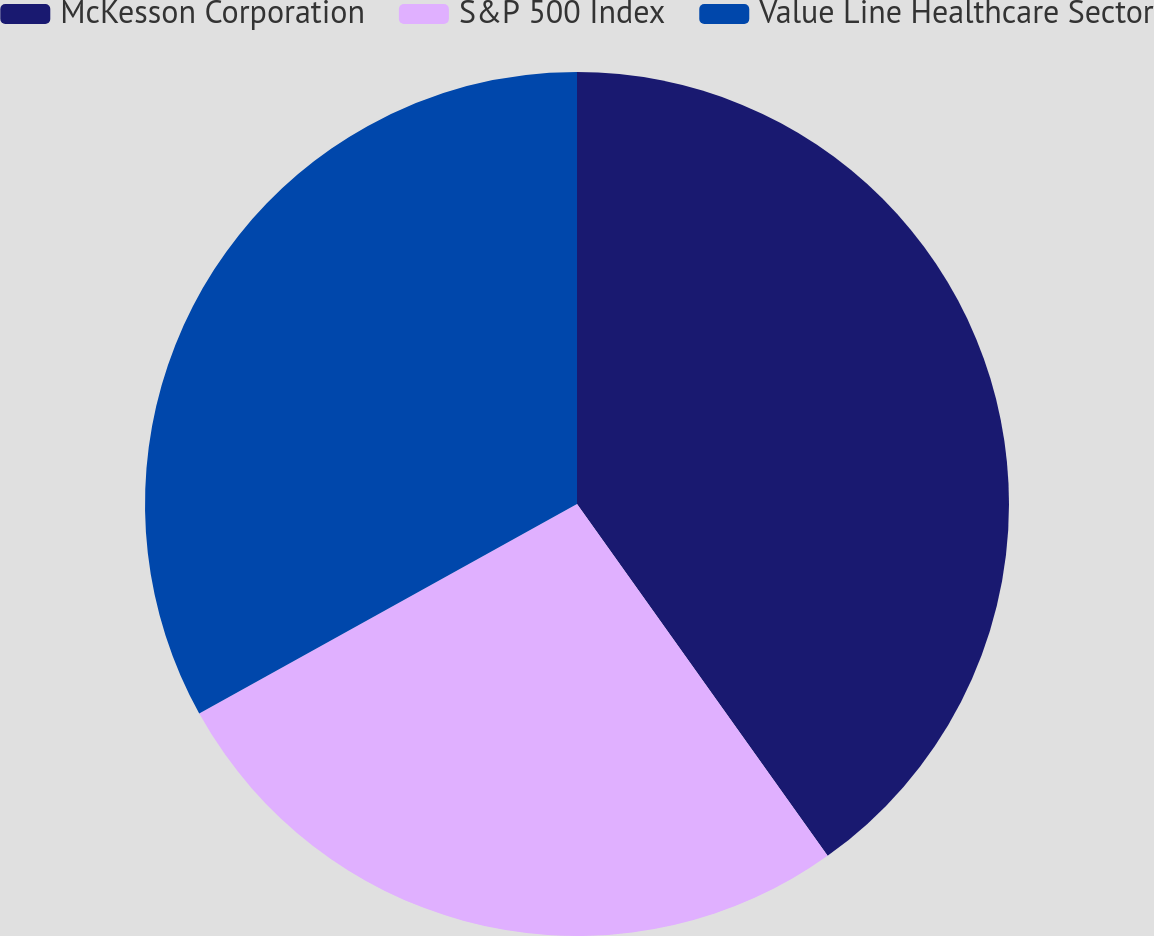<chart> <loc_0><loc_0><loc_500><loc_500><pie_chart><fcel>McKesson Corporation<fcel>S&P 500 Index<fcel>Value Line Healthcare Sector<nl><fcel>40.15%<fcel>26.79%<fcel>33.06%<nl></chart> 